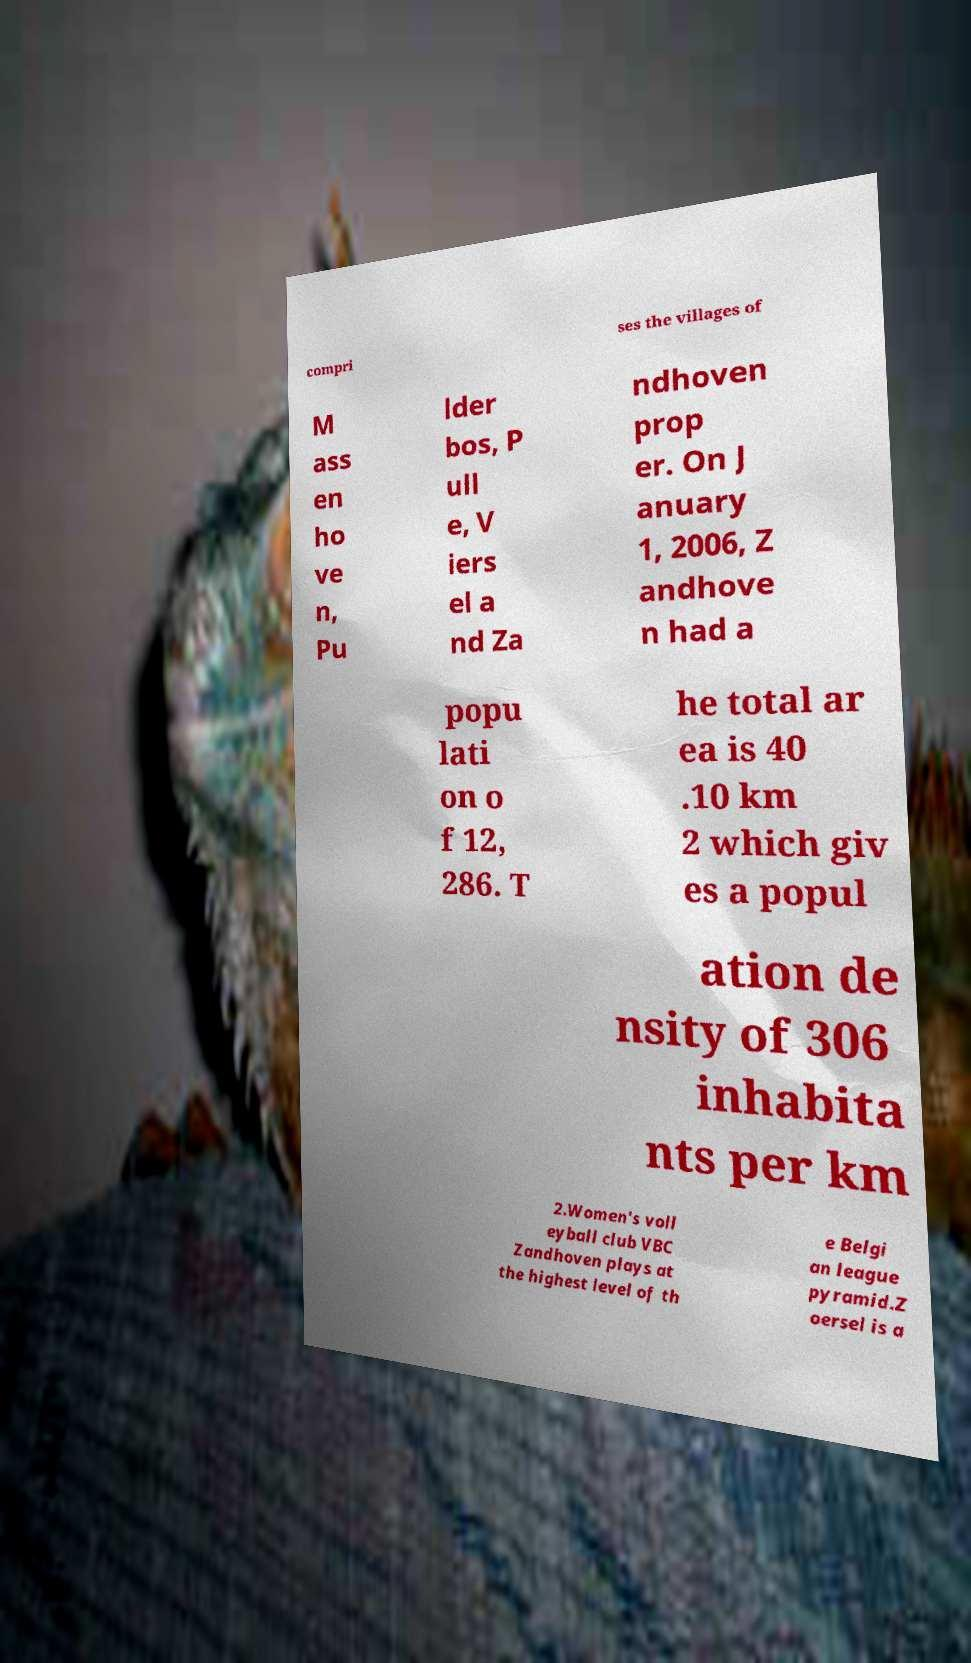Can you read and provide the text displayed in the image?This photo seems to have some interesting text. Can you extract and type it out for me? compri ses the villages of M ass en ho ve n, Pu lder bos, P ull e, V iers el a nd Za ndhoven prop er. On J anuary 1, 2006, Z andhove n had a popu lati on o f 12, 286. T he total ar ea is 40 .10 km 2 which giv es a popul ation de nsity of 306 inhabita nts per km 2.Women's voll eyball club VBC Zandhoven plays at the highest level of th e Belgi an league pyramid.Z oersel is a 